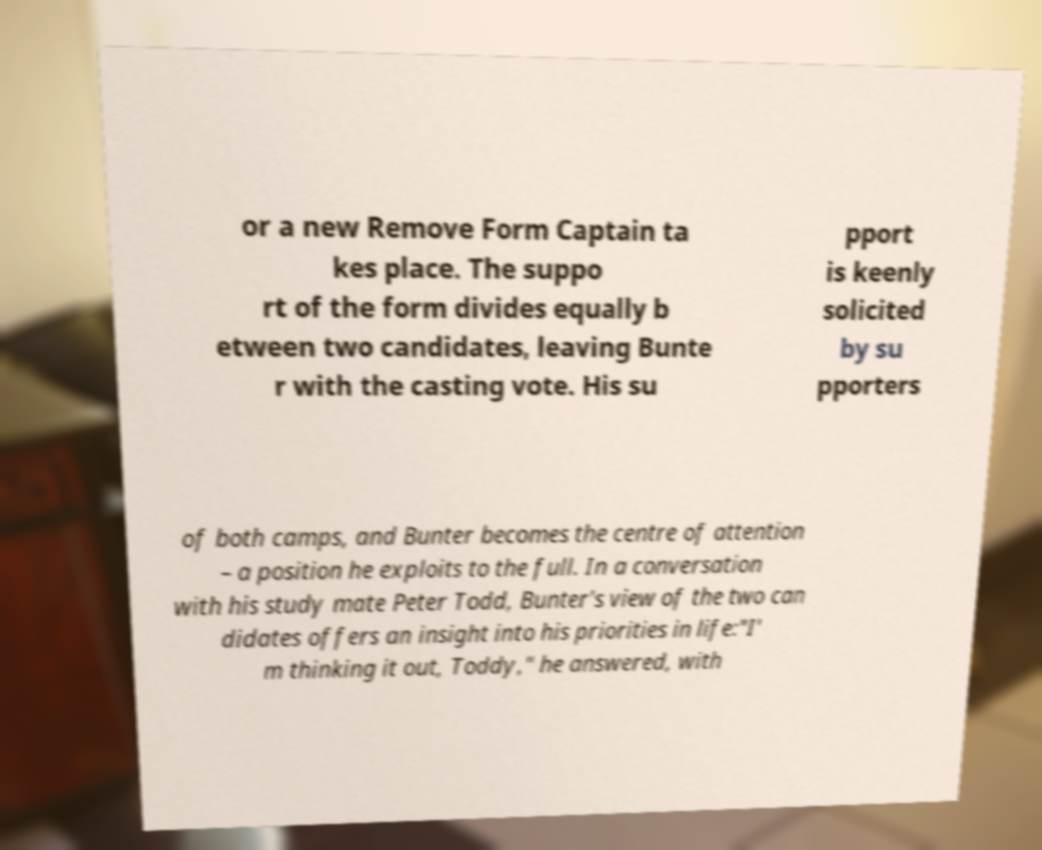Please read and relay the text visible in this image. What does it say? or a new Remove Form Captain ta kes place. The suppo rt of the form divides equally b etween two candidates, leaving Bunte r with the casting vote. His su pport is keenly solicited by su pporters of both camps, and Bunter becomes the centre of attention – a position he exploits to the full. In a conversation with his study mate Peter Todd, Bunter's view of the two can didates offers an insight into his priorities in life:"I' m thinking it out, Toddy," he answered, with 